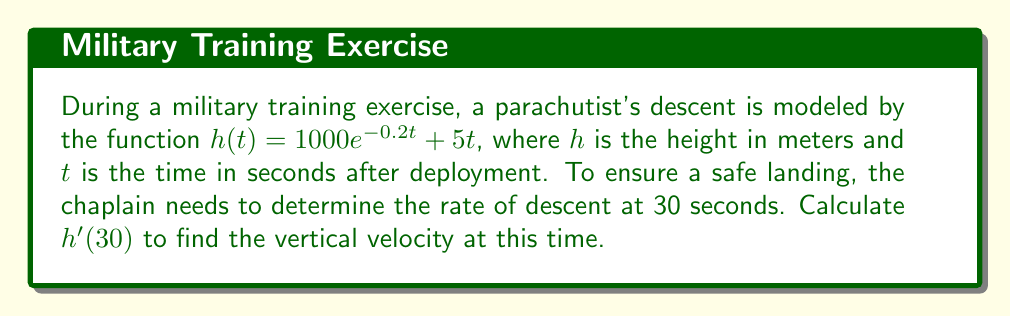Give your solution to this math problem. To solve this problem, we'll follow these steps:

1) First, we need to find the derivative of $h(t)$ with respect to $t$.

   $h(t) = 1000e^{-0.2t} + 5t$

   Using the chain rule for the exponential term and the power rule for the linear term:

   $h'(t) = 1000 \cdot (-0.2) \cdot e^{-0.2t} + 5$
   
   $h'(t) = -200e^{-0.2t} + 5$

2) Now that we have $h'(t)$, we can find the rate of descent at $t = 30$ by evaluating $h'(30)$:

   $h'(30) = -200e^{-0.2(30)} + 5$
   
   $= -200e^{-6} + 5$

3) Calculate $e^{-6}$:
   
   $e^{-6} \approx 0.00247875$

4) Substitute this value:

   $h'(30) = -200(0.00247875) + 5$
   
   $= -0.4957 + 5$
   
   $= 4.5043$

The positive value indicates upward velocity, so we need to negate it for the descent rate.
Answer: $-4.5043$ m/s 